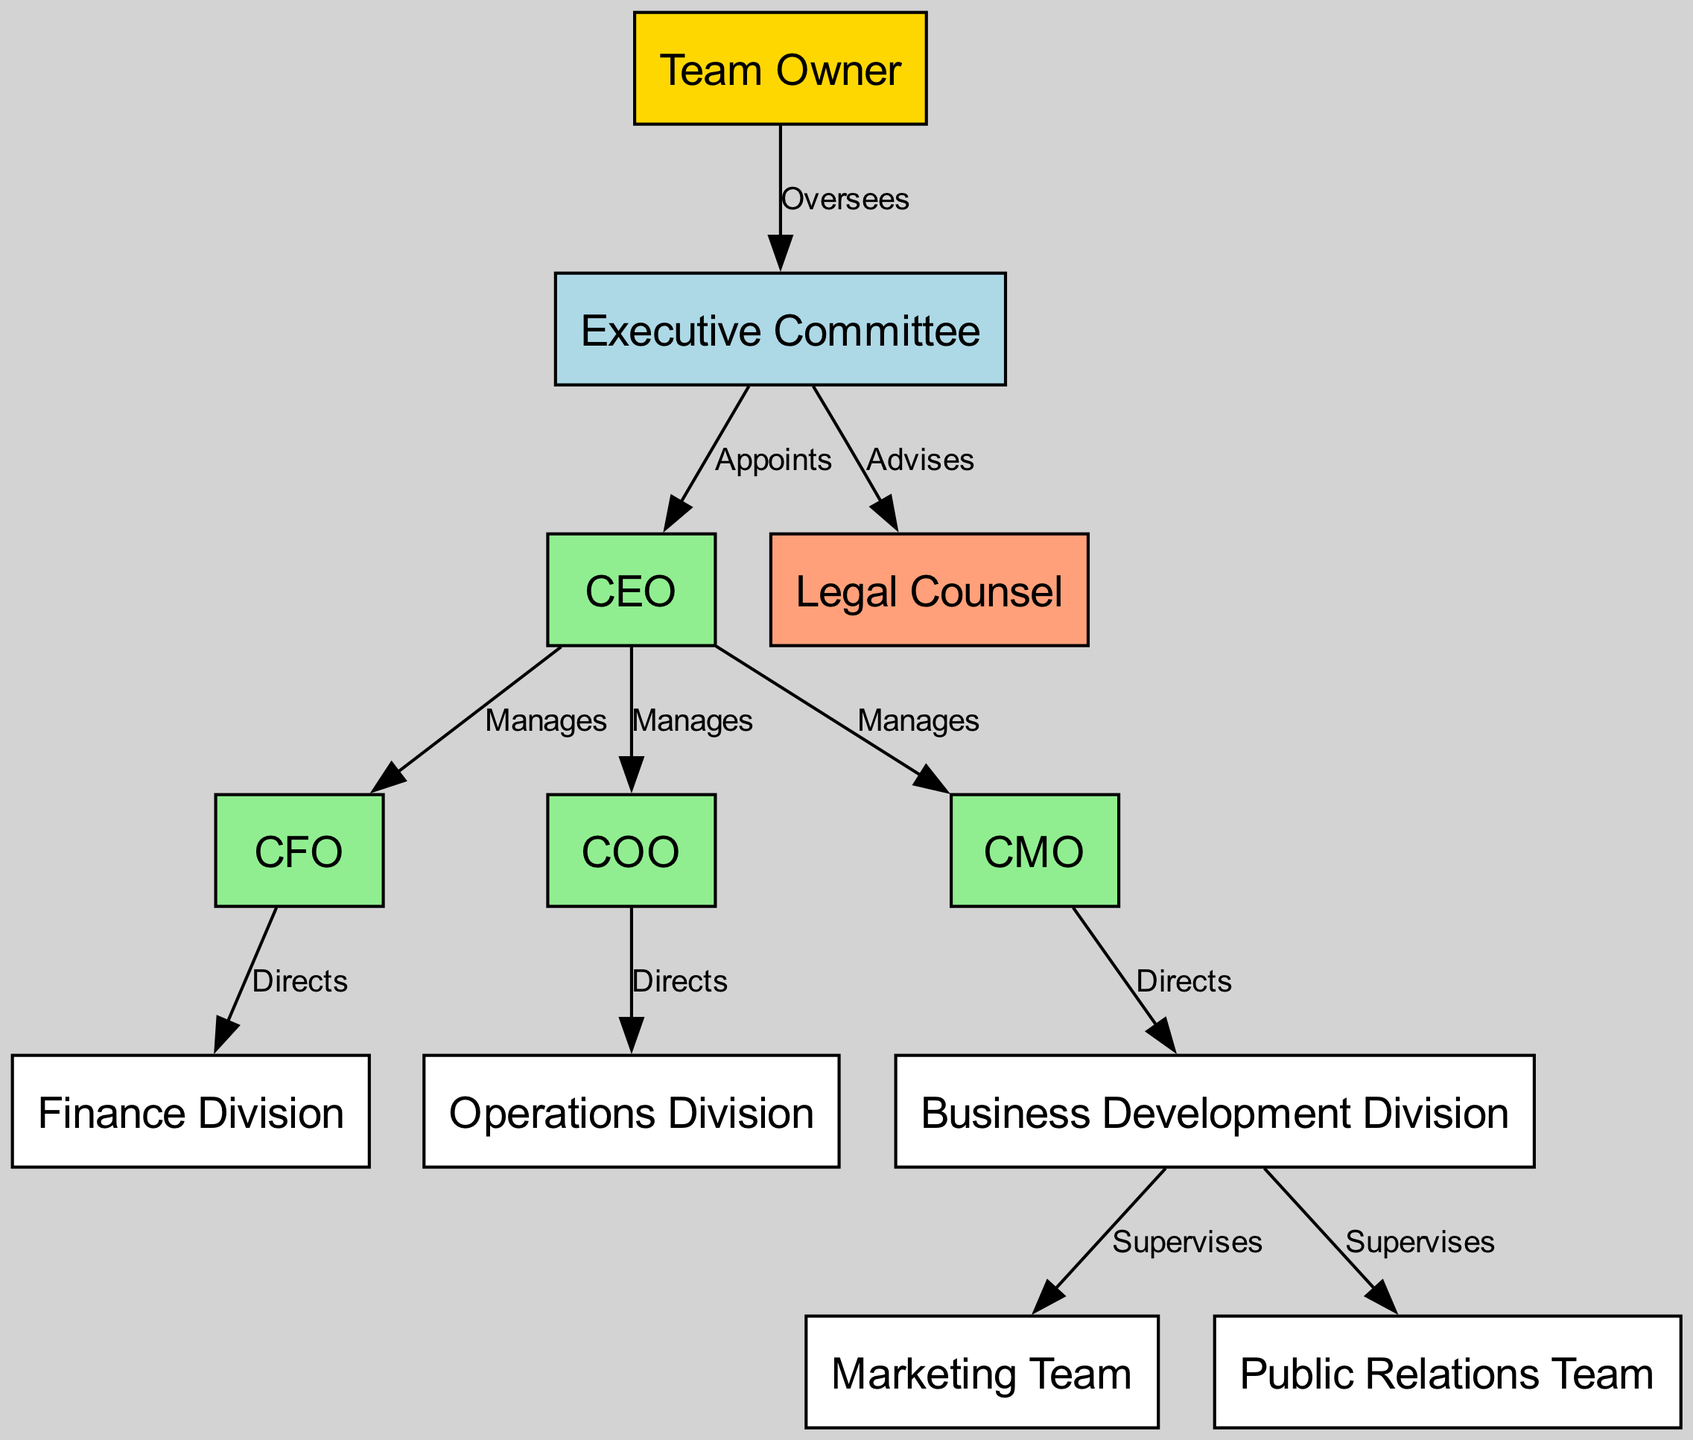What is the highest position in the team hierarchy? The topmost node in the diagram represents the highest position, which is the "Team Owner." This node has edges connecting it to the next level, namely the "Executive Committee."
Answer: Team Owner How many direct reports does the CEO have? The CEO is connected to three other nodes: CFO, COO, and CMO. Each of these nodes represents a direct report of the CEO. Counting these connections confirms the answer.
Answer: 3 Who advises the Executive Committee? The diagram indicates a directed edge from the "Executive Committee" to the "Legal Counsel," which signifies that the Legal Counsel provides advice. This relationship highlights the advisory position.
Answer: Legal Counsel Which division does the CFO direct? The CFO has a directed edge leading to the "Finance Division," indicating that the CFO is responsible for managing or directing that division. This direct connection identifies the specific division under the CFO's control.
Answer: Finance Division What is the relationship between the COO and the Operations Division? In the diagram, an edge exists from the COO to the Operations Division labeled "Directs." This indicates the COO has authority over this division, showing a clear managerial relationship.
Answer: Directs How many divisions are managed by the CMO? The CMO directs the "Business Development Division," which in turn supervises the "Marketing Team" and "Public Relations Team." Although two teams are supervised, the direct division managed is one.
Answer: 1 What is the main role of the Executive Committee? The diagram indicates that the Executive Committee appoints the CEO and advises the Legal Counsel, suggesting that its primary function revolves around governance and oversight of key roles within the organization.
Answer: Governs Which team does the Business Development Division supervise? The Business Development Division has two edges leading to the "Marketing Team" and the "Public Relations Team." Both connections denote supervision responsibilities. This shows the active roles exercised by the division.
Answer: Marketing Team, Public Relations Team What color represents the Team Owner in the diagram? The node for Team Owner is uniquely highlighted with the color gold, as specified in the diagram. This visual distinction allows easy identification of the highest hierarchical position based on color-coding.
Answer: Gold 